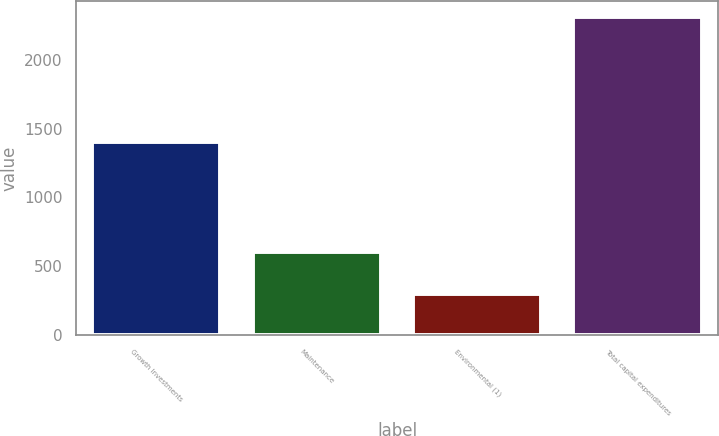Convert chart. <chart><loc_0><loc_0><loc_500><loc_500><bar_chart><fcel>Growth Investments<fcel>Maintenance<fcel>Environmental (1)<fcel>Total capital expenditures<nl><fcel>1401<fcel>606<fcel>301<fcel>2308<nl></chart> 